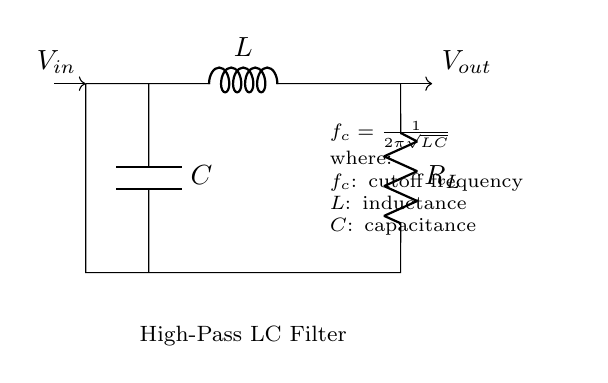What is the primary function of this circuit? The primary function of this high-pass filter circuit is to allow high-frequency signals to pass through while attenuating low-frequency signals, thereby eliminating low-frequency interference.
Answer: High-pass filter What are the components used in this circuit? The components in this circuit are an inductor (L), a capacitor (C), and a load resistor (R_L). These components are connected in a specific arrangement that defines the filter's characteristics.
Answer: Inductor, capacitor, load resistor What is the designation of the output voltage in the circuit? In the circuit, the output voltage is denoted as V_out, which is measured across the load resistor. This indicates that the output signal will primarily reflect the high-frequency signals that pass through the filter.
Answer: V_out What is the formula for calculating the cutoff frequency? The formula provided in the circuit indicates that the cutoff frequency f_c can be calculated using f_c = 1/(2π√(LC)). This formula is crucial for determining the frequency at which the circuit begins to attenuate signals.
Answer: f_c = 1/(2π√(LC)) How does increasing capacitance affect the cutoff frequency? Increasing the capacitance (C) in this circuit will lower the cutoff frequency (f_c). This is because the cutoff frequency is inversely related to the square root of the product of inductance and capacitance, impacting the frequency of signals allowed by the filter.
Answer: Lowers cutoff frequency What is the role of the inductor in this circuit? The inductor (L) in this high-pass filter circuit acts to resist changes in current flow, which helps to block low-frequency signals. This current-resisting property is essential for achieving the desired filtering effect.
Answer: Blocks low-frequency signals At what frequency does the cutoff occur? The cutoff frequency occurs at f_c, which is determined by the specific values of L and C within the circuit. The cutoff frequency separates the pass band from the attenuated frequencies in the filter operation.
Answer: f_c 